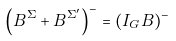<formula> <loc_0><loc_0><loc_500><loc_500>\left ( B ^ { \Sigma } + B ^ { \Sigma ^ { \prime } } \right ) ^ { - } = ( I _ { G } B ) ^ { - }</formula> 